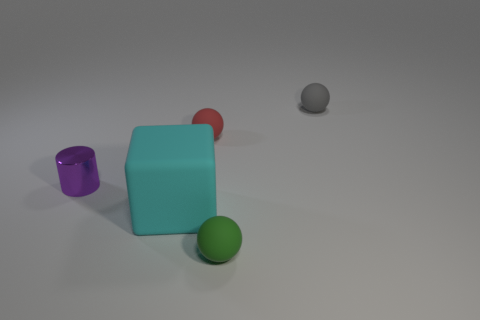What number of small things are blocks or gray rubber balls?
Your answer should be very brief. 1. Are there any other things of the same color as the small metallic cylinder?
Provide a short and direct response. No. How big is the thing that is both to the left of the tiny red matte sphere and on the right side of the purple metallic cylinder?
Your response must be concise. Large. Do the small matte object that is in front of the tiny purple object and the small object that is to the left of the big cube have the same color?
Your answer should be very brief. No. How many other things are the same material as the red thing?
Make the answer very short. 3. What shape is the object that is on the right side of the big cyan block and in front of the purple cylinder?
Ensure brevity in your answer.  Sphere. Is the color of the large rubber block the same as the tiny thing that is in front of the cylinder?
Provide a short and direct response. No. Is the size of the rubber sphere behind the red matte sphere the same as the purple thing?
Your response must be concise. Yes. There is a small red thing that is the same shape as the green rubber object; what is it made of?
Provide a short and direct response. Rubber. Is the shape of the small gray matte thing the same as the small green object?
Your response must be concise. Yes. 